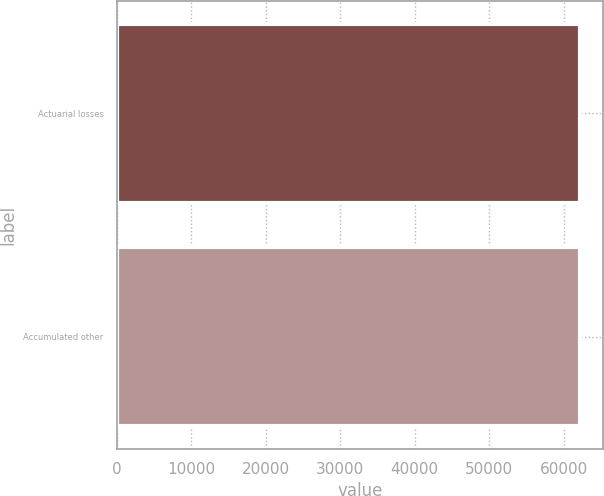Convert chart. <chart><loc_0><loc_0><loc_500><loc_500><bar_chart><fcel>Actuarial losses<fcel>Accumulated other<nl><fcel>62226<fcel>62226.1<nl></chart> 